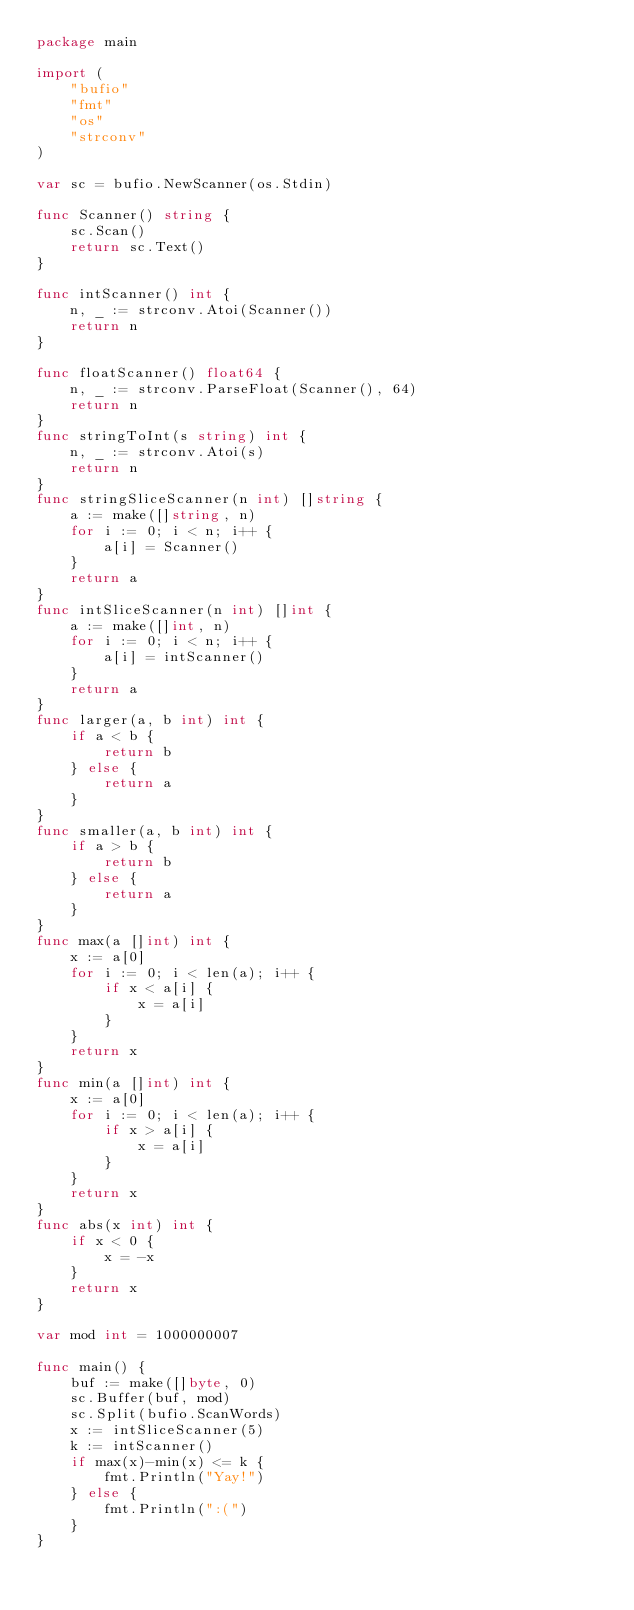<code> <loc_0><loc_0><loc_500><loc_500><_Go_>package main

import (
	"bufio"
	"fmt"
	"os"
	"strconv"
)

var sc = bufio.NewScanner(os.Stdin)

func Scanner() string {
	sc.Scan()
	return sc.Text()
}

func intScanner() int {
	n, _ := strconv.Atoi(Scanner())
	return n
}

func floatScanner() float64 {
	n, _ := strconv.ParseFloat(Scanner(), 64)
	return n
}
func stringToInt(s string) int {
	n, _ := strconv.Atoi(s)
	return n
}
func stringSliceScanner(n int) []string {
	a := make([]string, n)
	for i := 0; i < n; i++ {
		a[i] = Scanner()
	}
	return a
}
func intSliceScanner(n int) []int {
	a := make([]int, n)
	for i := 0; i < n; i++ {
		a[i] = intScanner()
	}
	return a
}
func larger(a, b int) int {
	if a < b {
		return b
	} else {
		return a
	}
}
func smaller(a, b int) int {
	if a > b {
		return b
	} else {
		return a
	}
}
func max(a []int) int {
	x := a[0]
	for i := 0; i < len(a); i++ {
		if x < a[i] {
			x = a[i]
		}
	}
	return x
}
func min(a []int) int {
	x := a[0]
	for i := 0; i < len(a); i++ {
		if x > a[i] {
			x = a[i]
		}
	}
	return x
}
func abs(x int) int {
	if x < 0 {
		x = -x
	}
	return x
}

var mod int = 1000000007

func main() {
	buf := make([]byte, 0)
	sc.Buffer(buf, mod)
	sc.Split(bufio.ScanWords)
	x := intSliceScanner(5)
	k := intScanner()
	if max(x)-min(x) <= k {
		fmt.Println("Yay!")
	} else {
		fmt.Println(":(")
	}
}
</code> 